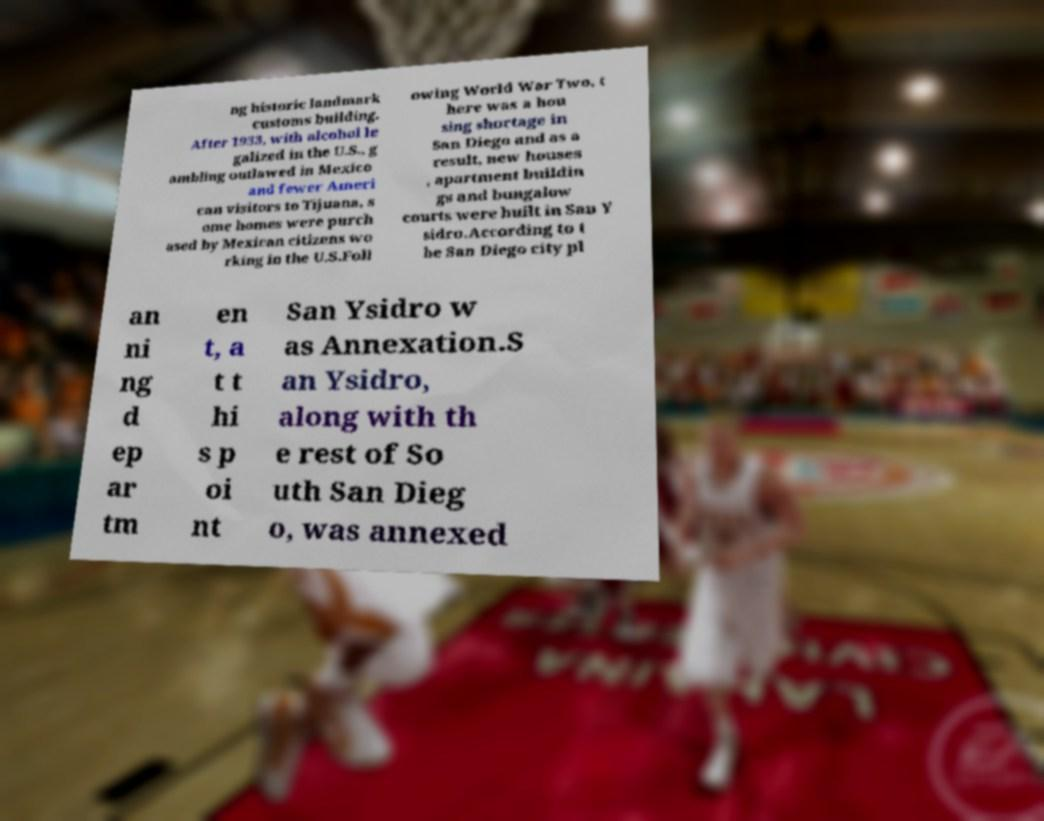Please read and relay the text visible in this image. What does it say? ng historic landmark customs building. After 1933, with alcohol le galized in the U.S., g ambling outlawed in Mexico and fewer Ameri can visitors to Tijuana, s ome homes were purch ased by Mexican citizens wo rking in the U.S.Foll owing World War Two, t here was a hou sing shortage in San Diego and as a result, new houses , apartment buildin gs and bungalow courts were built in San Y sidro.According to t he San Diego city pl an ni ng d ep ar tm en t, a t t hi s p oi nt San Ysidro w as Annexation.S an Ysidro, along with th e rest of So uth San Dieg o, was annexed 